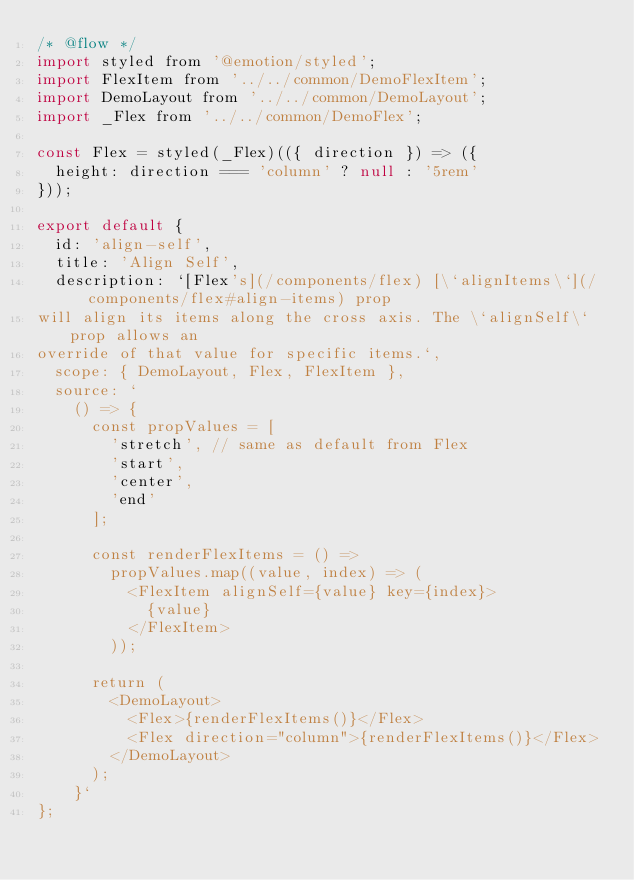<code> <loc_0><loc_0><loc_500><loc_500><_JavaScript_>/* @flow */
import styled from '@emotion/styled';
import FlexItem from '../../common/DemoFlexItem';
import DemoLayout from '../../common/DemoLayout';
import _Flex from '../../common/DemoFlex';

const Flex = styled(_Flex)(({ direction }) => ({
  height: direction === 'column' ? null : '5rem'
}));

export default {
  id: 'align-self',
  title: 'Align Self',
  description: `[Flex's](/components/flex) [\`alignItems\`](/components/flex#align-items) prop
will align its items along the cross axis. The \`alignSelf\` prop allows an
override of that value for specific items.`,
  scope: { DemoLayout, Flex, FlexItem },
  source: `
    () => {
      const propValues = [
        'stretch', // same as default from Flex
        'start',
        'center',
        'end'
      ];

      const renderFlexItems = () =>
        propValues.map((value, index) => (
          <FlexItem alignSelf={value} key={index}>
            {value}
          </FlexItem>
        ));

      return (
        <DemoLayout>
          <Flex>{renderFlexItems()}</Flex>
          <Flex direction="column">{renderFlexItems()}</Flex>
        </DemoLayout>
      );
    }`
};
</code> 